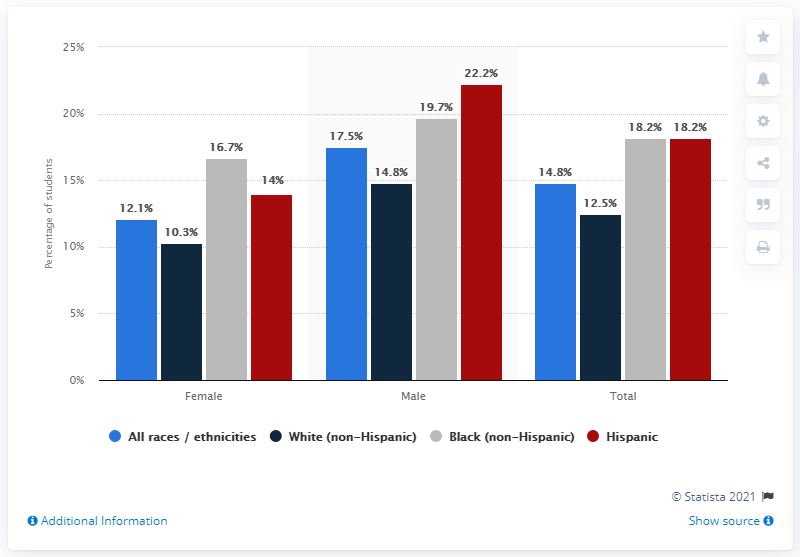Indicate a few pertinent items in this graphic. According to data from 2016 to 2017, 22.2% of male students with a Hispanic background were reported to be obese. 